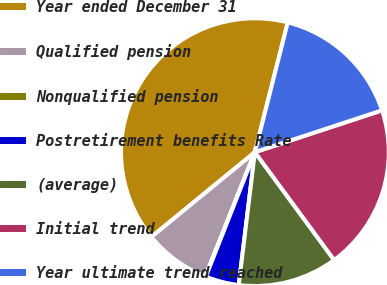Convert chart. <chart><loc_0><loc_0><loc_500><loc_500><pie_chart><fcel>Year ended December 31<fcel>Qualified pension<fcel>Nonqualified pension<fcel>Postretirement benefits Rate<fcel>(average)<fcel>Initial trend<fcel>Year ultimate trend reached<nl><fcel>39.87%<fcel>8.03%<fcel>0.07%<fcel>4.05%<fcel>12.01%<fcel>19.97%<fcel>15.99%<nl></chart> 